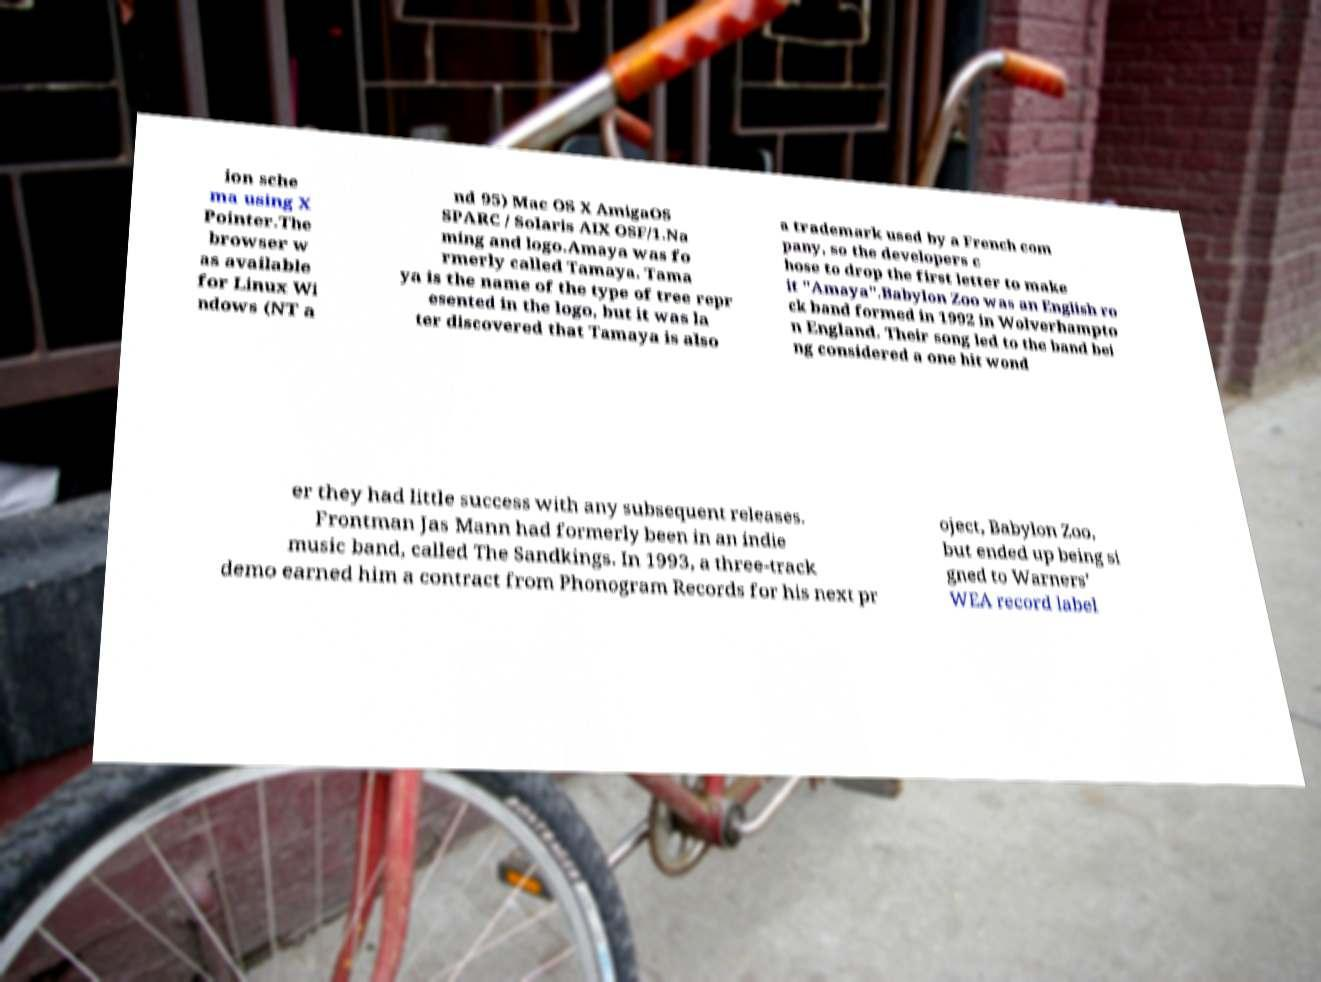I need the written content from this picture converted into text. Can you do that? ion sche ma using X Pointer.The browser w as available for Linux Wi ndows (NT a nd 95) Mac OS X AmigaOS SPARC / Solaris AIX OSF/1.Na ming and logo.Amaya was fo rmerly called Tamaya. Tama ya is the name of the type of tree repr esented in the logo, but it was la ter discovered that Tamaya is also a trademark used by a French com pany, so the developers c hose to drop the first letter to make it "Amaya".Babylon Zoo was an English ro ck band formed in 1992 in Wolverhampto n England. Their song led to the band bei ng considered a one hit wond er they had little success with any subsequent releases. Frontman Jas Mann had formerly been in an indie music band, called The Sandkings. In 1993, a three-track demo earned him a contract from Phonogram Records for his next pr oject, Babylon Zoo, but ended up being si gned to Warners' WEA record label 